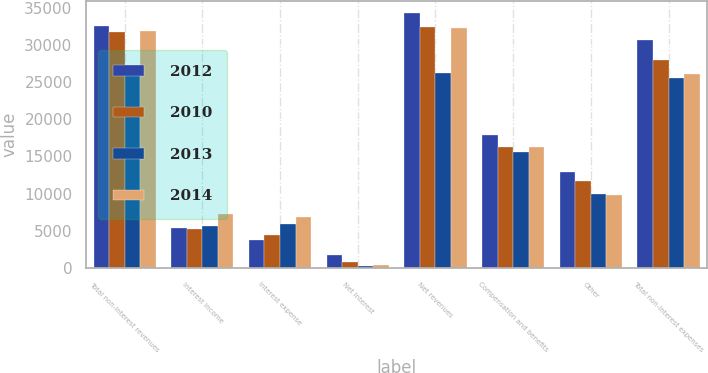<chart> <loc_0><loc_0><loc_500><loc_500><stacked_bar_chart><ecel><fcel>Total non-interest revenues<fcel>Interest income<fcel>Interest expense<fcel>Net interest<fcel>Net revenues<fcel>Compensation and benefits<fcel>Other<fcel>Total non-interest expenses<nl><fcel>2012<fcel>32540<fcel>5413<fcel>3678<fcel>1735<fcel>34275<fcel>17824<fcel>12860<fcel>30684<nl><fcel>2010<fcel>31715<fcel>5209<fcel>4431<fcel>778<fcel>32493<fcel>16277<fcel>11658<fcel>27935<nl><fcel>2013<fcel>26383<fcel>5692<fcel>5897<fcel>205<fcel>26178<fcel>15615<fcel>9967<fcel>25582<nl><fcel>2014<fcel>31953<fcel>7234<fcel>6883<fcel>351<fcel>32304<fcel>16325<fcel>9792<fcel>26117<nl></chart> 